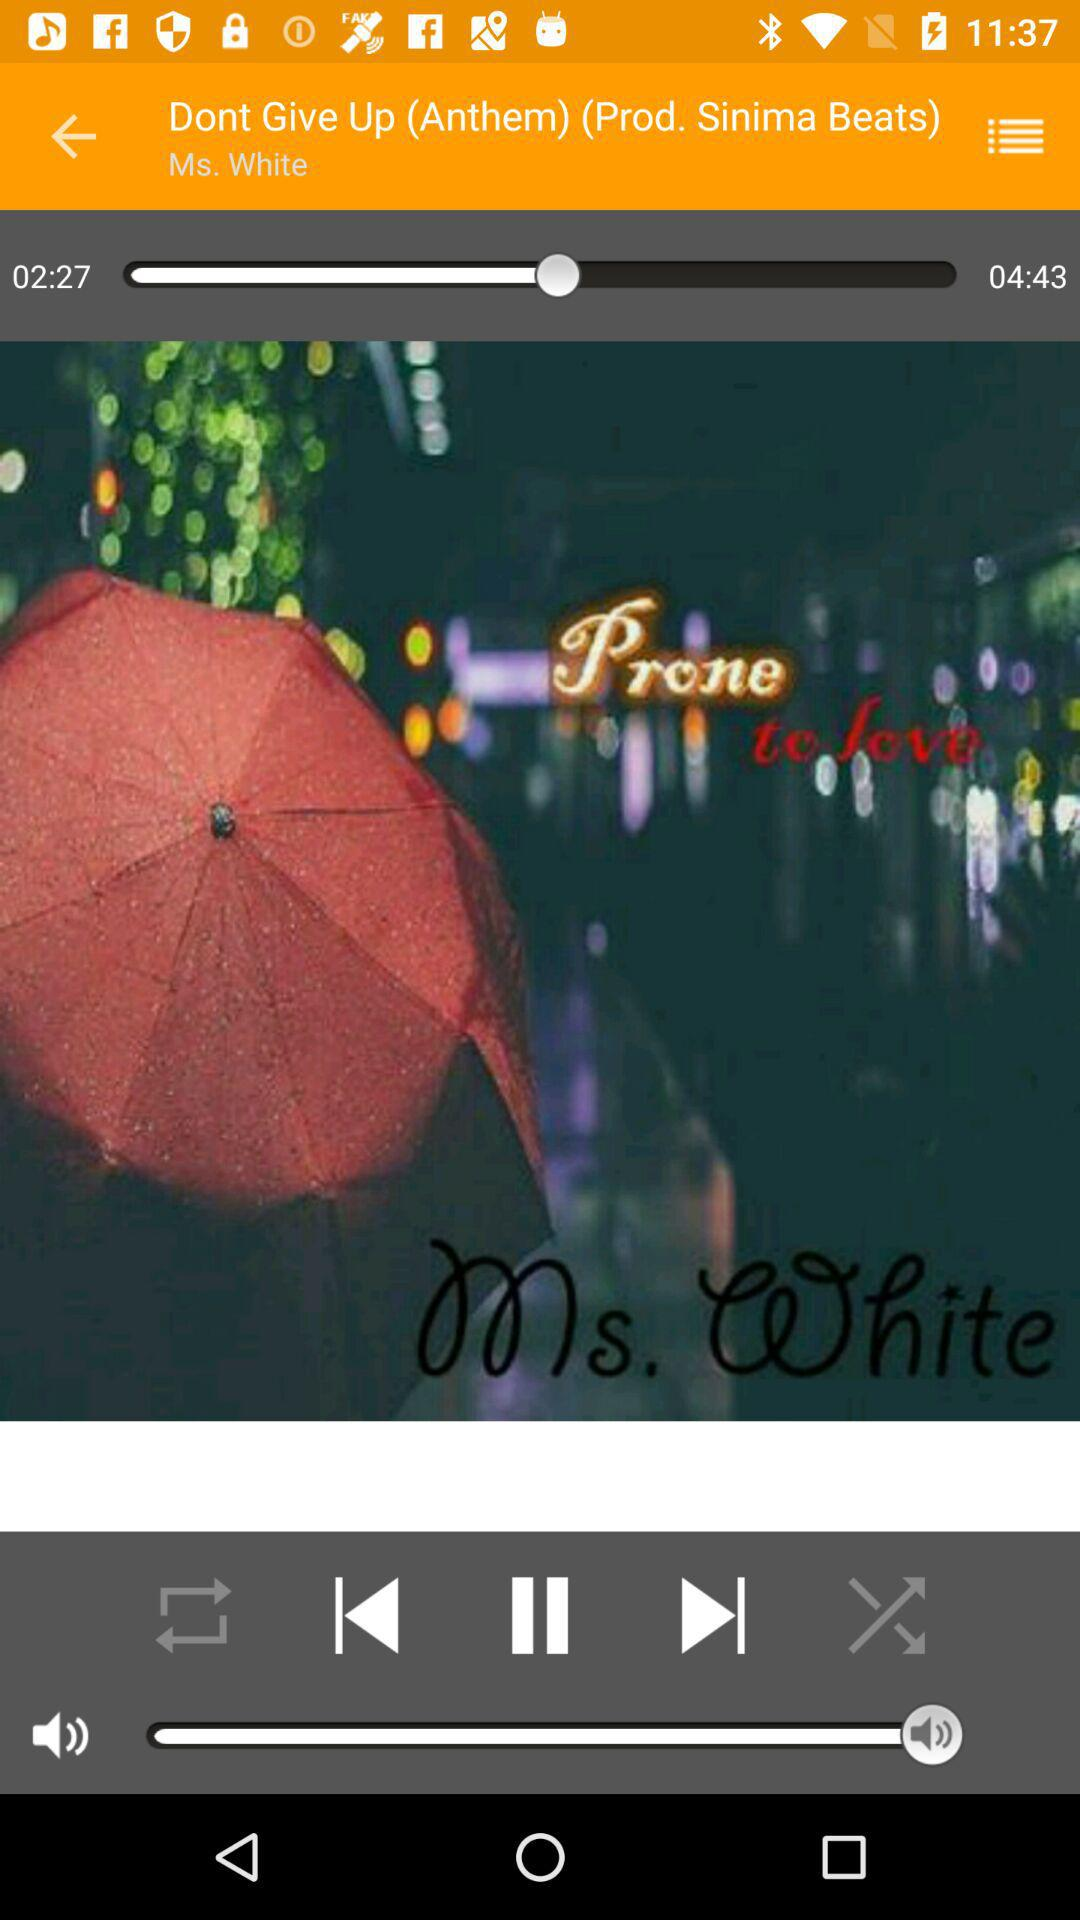What song is playing? The song "Dont Give Up (Anthem)" is playing. 